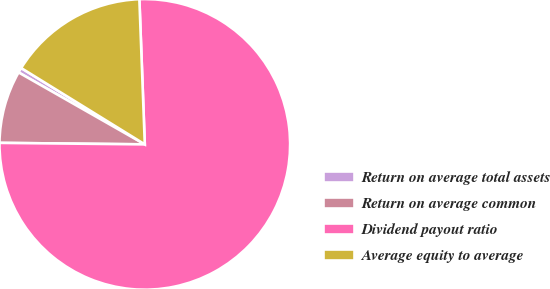Convert chart. <chart><loc_0><loc_0><loc_500><loc_500><pie_chart><fcel>Return on average total assets<fcel>Return on average common<fcel>Dividend payout ratio<fcel>Average equity to average<nl><fcel>0.56%<fcel>8.08%<fcel>75.76%<fcel>15.6%<nl></chart> 